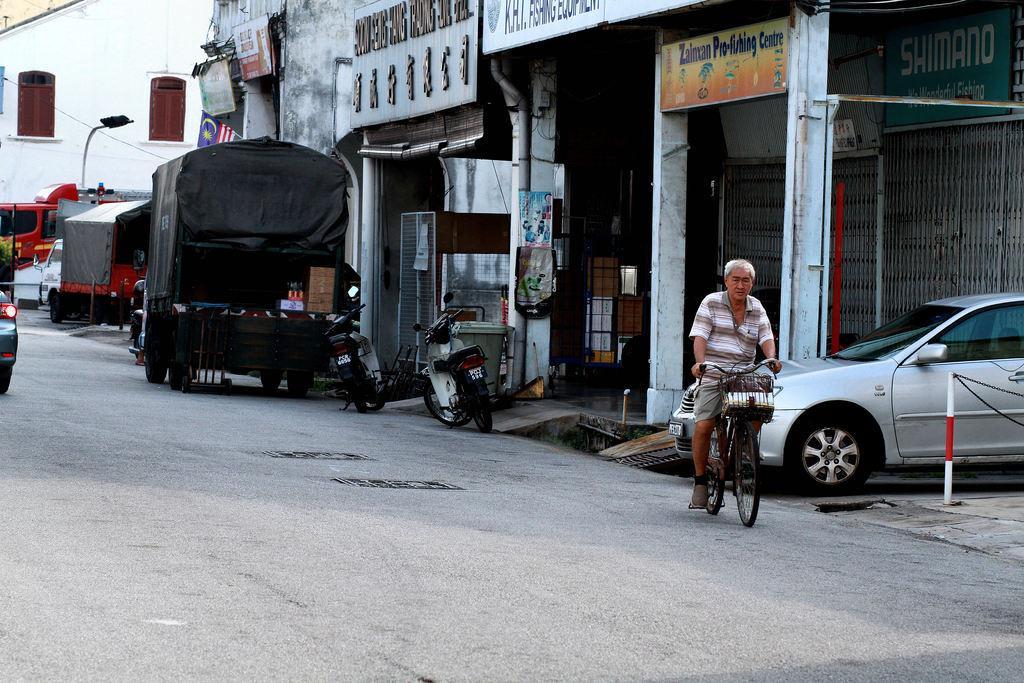Can you describe this image briefly? In the picture we can see a road on it we can see a man riding bicycle and behind him we can see some motor cycles and some vehicles are parked near the shops and behind the man we can see a car is parked beside the shop and in the background we can see a house which is white in color with two windows. 